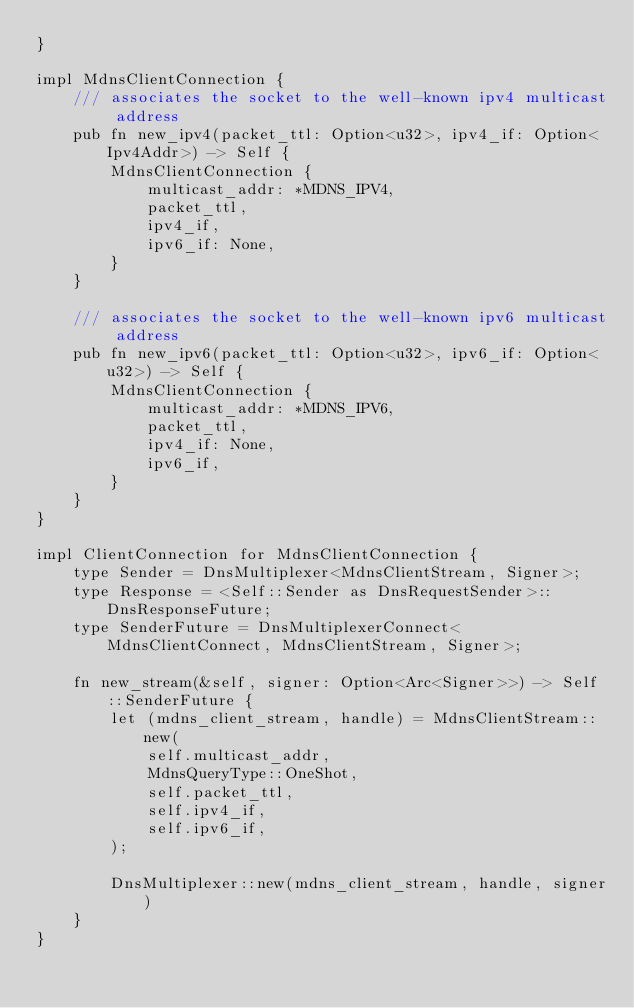Convert code to text. <code><loc_0><loc_0><loc_500><loc_500><_Rust_>}

impl MdnsClientConnection {
    /// associates the socket to the well-known ipv4 multicast address
    pub fn new_ipv4(packet_ttl: Option<u32>, ipv4_if: Option<Ipv4Addr>) -> Self {
        MdnsClientConnection {
            multicast_addr: *MDNS_IPV4,
            packet_ttl,
            ipv4_if,
            ipv6_if: None,
        }
    }

    /// associates the socket to the well-known ipv6 multicast address
    pub fn new_ipv6(packet_ttl: Option<u32>, ipv6_if: Option<u32>) -> Self {
        MdnsClientConnection {
            multicast_addr: *MDNS_IPV6,
            packet_ttl,
            ipv4_if: None,
            ipv6_if,
        }
    }
}

impl ClientConnection for MdnsClientConnection {
    type Sender = DnsMultiplexer<MdnsClientStream, Signer>;
    type Response = <Self::Sender as DnsRequestSender>::DnsResponseFuture;
    type SenderFuture = DnsMultiplexerConnect<MdnsClientConnect, MdnsClientStream, Signer>;

    fn new_stream(&self, signer: Option<Arc<Signer>>) -> Self::SenderFuture {
        let (mdns_client_stream, handle) = MdnsClientStream::new(
            self.multicast_addr,
            MdnsQueryType::OneShot,
            self.packet_ttl,
            self.ipv4_if,
            self.ipv6_if,
        );

        DnsMultiplexer::new(mdns_client_stream, handle, signer)
    }
}
</code> 